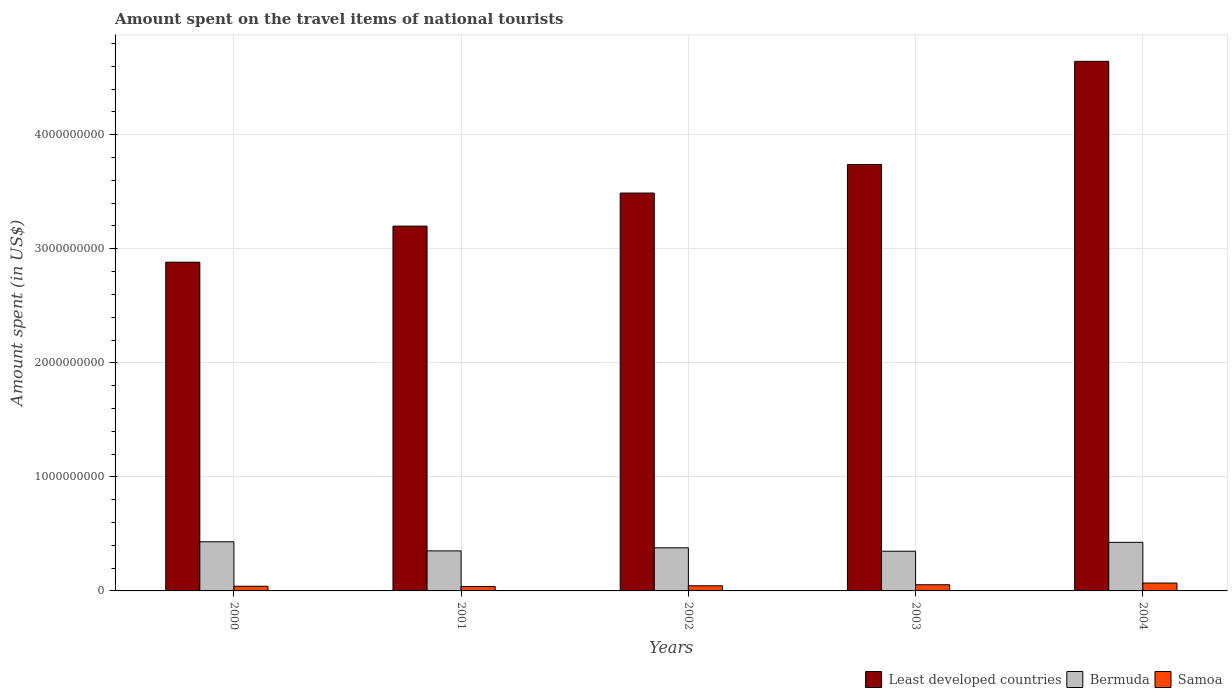How many different coloured bars are there?
Ensure brevity in your answer.  3. How many groups of bars are there?
Keep it short and to the point. 5. How many bars are there on the 4th tick from the left?
Your answer should be very brief. 3. How many bars are there on the 2nd tick from the right?
Provide a short and direct response. 3. In how many cases, is the number of bars for a given year not equal to the number of legend labels?
Make the answer very short. 0. What is the amount spent on the travel items of national tourists in Samoa in 2002?
Your answer should be compact. 4.50e+07. Across all years, what is the maximum amount spent on the travel items of national tourists in Least developed countries?
Your answer should be compact. 4.64e+09. Across all years, what is the minimum amount spent on the travel items of national tourists in Samoa?
Offer a terse response. 3.90e+07. In which year was the amount spent on the travel items of national tourists in Samoa maximum?
Provide a short and direct response. 2004. In which year was the amount spent on the travel items of national tourists in Bermuda minimum?
Your response must be concise. 2003. What is the total amount spent on the travel items of national tourists in Least developed countries in the graph?
Your response must be concise. 1.80e+1. What is the difference between the amount spent on the travel items of national tourists in Bermuda in 2001 and that in 2002?
Your answer should be very brief. -2.70e+07. What is the difference between the amount spent on the travel items of national tourists in Bermuda in 2000 and the amount spent on the travel items of national tourists in Samoa in 2002?
Give a very brief answer. 3.86e+08. What is the average amount spent on the travel items of national tourists in Bermuda per year?
Keep it short and to the point. 3.87e+08. In the year 2004, what is the difference between the amount spent on the travel items of national tourists in Samoa and amount spent on the travel items of national tourists in Bermuda?
Keep it short and to the point. -3.57e+08. In how many years, is the amount spent on the travel items of national tourists in Bermuda greater than 4600000000 US$?
Your answer should be compact. 0. What is the ratio of the amount spent on the travel items of national tourists in Samoa in 2001 to that in 2002?
Provide a short and direct response. 0.87. Is the amount spent on the travel items of national tourists in Samoa in 2000 less than that in 2003?
Keep it short and to the point. Yes. Is the difference between the amount spent on the travel items of national tourists in Samoa in 2000 and 2004 greater than the difference between the amount spent on the travel items of national tourists in Bermuda in 2000 and 2004?
Your answer should be compact. No. What is the difference between the highest and the second highest amount spent on the travel items of national tourists in Samoa?
Make the answer very short. 1.50e+07. What is the difference between the highest and the lowest amount spent on the travel items of national tourists in Samoa?
Your response must be concise. 3.00e+07. In how many years, is the amount spent on the travel items of national tourists in Bermuda greater than the average amount spent on the travel items of national tourists in Bermuda taken over all years?
Provide a short and direct response. 2. Is the sum of the amount spent on the travel items of national tourists in Bermuda in 2002 and 2004 greater than the maximum amount spent on the travel items of national tourists in Samoa across all years?
Offer a very short reply. Yes. What does the 3rd bar from the left in 2003 represents?
Provide a succinct answer. Samoa. What does the 3rd bar from the right in 2002 represents?
Your response must be concise. Least developed countries. Are all the bars in the graph horizontal?
Provide a short and direct response. No. Are the values on the major ticks of Y-axis written in scientific E-notation?
Keep it short and to the point. No. Where does the legend appear in the graph?
Give a very brief answer. Bottom right. How many legend labels are there?
Make the answer very short. 3. How are the legend labels stacked?
Make the answer very short. Horizontal. What is the title of the graph?
Make the answer very short. Amount spent on the travel items of national tourists. Does "Sub-Saharan Africa (developing only)" appear as one of the legend labels in the graph?
Offer a very short reply. No. What is the label or title of the Y-axis?
Offer a terse response. Amount spent (in US$). What is the Amount spent (in US$) in Least developed countries in 2000?
Your answer should be compact. 2.88e+09. What is the Amount spent (in US$) in Bermuda in 2000?
Ensure brevity in your answer.  4.31e+08. What is the Amount spent (in US$) in Samoa in 2000?
Make the answer very short. 4.10e+07. What is the Amount spent (in US$) in Least developed countries in 2001?
Your response must be concise. 3.20e+09. What is the Amount spent (in US$) of Bermuda in 2001?
Give a very brief answer. 3.51e+08. What is the Amount spent (in US$) of Samoa in 2001?
Give a very brief answer. 3.90e+07. What is the Amount spent (in US$) in Least developed countries in 2002?
Your answer should be compact. 3.49e+09. What is the Amount spent (in US$) of Bermuda in 2002?
Offer a terse response. 3.78e+08. What is the Amount spent (in US$) in Samoa in 2002?
Provide a succinct answer. 4.50e+07. What is the Amount spent (in US$) of Least developed countries in 2003?
Your answer should be very brief. 3.74e+09. What is the Amount spent (in US$) of Bermuda in 2003?
Offer a very short reply. 3.48e+08. What is the Amount spent (in US$) of Samoa in 2003?
Keep it short and to the point. 5.40e+07. What is the Amount spent (in US$) of Least developed countries in 2004?
Make the answer very short. 4.64e+09. What is the Amount spent (in US$) in Bermuda in 2004?
Provide a short and direct response. 4.26e+08. What is the Amount spent (in US$) in Samoa in 2004?
Your answer should be compact. 6.90e+07. Across all years, what is the maximum Amount spent (in US$) in Least developed countries?
Provide a short and direct response. 4.64e+09. Across all years, what is the maximum Amount spent (in US$) of Bermuda?
Provide a short and direct response. 4.31e+08. Across all years, what is the maximum Amount spent (in US$) in Samoa?
Your answer should be compact. 6.90e+07. Across all years, what is the minimum Amount spent (in US$) in Least developed countries?
Your response must be concise. 2.88e+09. Across all years, what is the minimum Amount spent (in US$) of Bermuda?
Offer a very short reply. 3.48e+08. Across all years, what is the minimum Amount spent (in US$) of Samoa?
Offer a terse response. 3.90e+07. What is the total Amount spent (in US$) in Least developed countries in the graph?
Give a very brief answer. 1.80e+1. What is the total Amount spent (in US$) of Bermuda in the graph?
Make the answer very short. 1.93e+09. What is the total Amount spent (in US$) in Samoa in the graph?
Ensure brevity in your answer.  2.48e+08. What is the difference between the Amount spent (in US$) of Least developed countries in 2000 and that in 2001?
Provide a short and direct response. -3.16e+08. What is the difference between the Amount spent (in US$) of Bermuda in 2000 and that in 2001?
Your answer should be very brief. 8.00e+07. What is the difference between the Amount spent (in US$) of Least developed countries in 2000 and that in 2002?
Make the answer very short. -6.06e+08. What is the difference between the Amount spent (in US$) in Bermuda in 2000 and that in 2002?
Make the answer very short. 5.30e+07. What is the difference between the Amount spent (in US$) in Samoa in 2000 and that in 2002?
Provide a succinct answer. -4.00e+06. What is the difference between the Amount spent (in US$) in Least developed countries in 2000 and that in 2003?
Make the answer very short. -8.57e+08. What is the difference between the Amount spent (in US$) of Bermuda in 2000 and that in 2003?
Your answer should be very brief. 8.30e+07. What is the difference between the Amount spent (in US$) in Samoa in 2000 and that in 2003?
Provide a succinct answer. -1.30e+07. What is the difference between the Amount spent (in US$) in Least developed countries in 2000 and that in 2004?
Provide a short and direct response. -1.76e+09. What is the difference between the Amount spent (in US$) of Bermuda in 2000 and that in 2004?
Keep it short and to the point. 5.00e+06. What is the difference between the Amount spent (in US$) of Samoa in 2000 and that in 2004?
Provide a succinct answer. -2.80e+07. What is the difference between the Amount spent (in US$) of Least developed countries in 2001 and that in 2002?
Ensure brevity in your answer.  -2.90e+08. What is the difference between the Amount spent (in US$) of Bermuda in 2001 and that in 2002?
Offer a terse response. -2.70e+07. What is the difference between the Amount spent (in US$) in Samoa in 2001 and that in 2002?
Provide a short and direct response. -6.00e+06. What is the difference between the Amount spent (in US$) in Least developed countries in 2001 and that in 2003?
Provide a short and direct response. -5.40e+08. What is the difference between the Amount spent (in US$) of Bermuda in 2001 and that in 2003?
Ensure brevity in your answer.  3.00e+06. What is the difference between the Amount spent (in US$) in Samoa in 2001 and that in 2003?
Ensure brevity in your answer.  -1.50e+07. What is the difference between the Amount spent (in US$) in Least developed countries in 2001 and that in 2004?
Your answer should be compact. -1.44e+09. What is the difference between the Amount spent (in US$) in Bermuda in 2001 and that in 2004?
Provide a short and direct response. -7.50e+07. What is the difference between the Amount spent (in US$) in Samoa in 2001 and that in 2004?
Keep it short and to the point. -3.00e+07. What is the difference between the Amount spent (in US$) of Least developed countries in 2002 and that in 2003?
Give a very brief answer. -2.50e+08. What is the difference between the Amount spent (in US$) in Bermuda in 2002 and that in 2003?
Ensure brevity in your answer.  3.00e+07. What is the difference between the Amount spent (in US$) in Samoa in 2002 and that in 2003?
Give a very brief answer. -9.00e+06. What is the difference between the Amount spent (in US$) in Least developed countries in 2002 and that in 2004?
Your response must be concise. -1.15e+09. What is the difference between the Amount spent (in US$) of Bermuda in 2002 and that in 2004?
Keep it short and to the point. -4.80e+07. What is the difference between the Amount spent (in US$) of Samoa in 2002 and that in 2004?
Your answer should be compact. -2.40e+07. What is the difference between the Amount spent (in US$) of Least developed countries in 2003 and that in 2004?
Provide a succinct answer. -9.05e+08. What is the difference between the Amount spent (in US$) in Bermuda in 2003 and that in 2004?
Make the answer very short. -7.80e+07. What is the difference between the Amount spent (in US$) in Samoa in 2003 and that in 2004?
Your answer should be compact. -1.50e+07. What is the difference between the Amount spent (in US$) in Least developed countries in 2000 and the Amount spent (in US$) in Bermuda in 2001?
Your response must be concise. 2.53e+09. What is the difference between the Amount spent (in US$) in Least developed countries in 2000 and the Amount spent (in US$) in Samoa in 2001?
Provide a short and direct response. 2.84e+09. What is the difference between the Amount spent (in US$) of Bermuda in 2000 and the Amount spent (in US$) of Samoa in 2001?
Keep it short and to the point. 3.92e+08. What is the difference between the Amount spent (in US$) in Least developed countries in 2000 and the Amount spent (in US$) in Bermuda in 2002?
Your answer should be very brief. 2.50e+09. What is the difference between the Amount spent (in US$) of Least developed countries in 2000 and the Amount spent (in US$) of Samoa in 2002?
Give a very brief answer. 2.84e+09. What is the difference between the Amount spent (in US$) of Bermuda in 2000 and the Amount spent (in US$) of Samoa in 2002?
Provide a short and direct response. 3.86e+08. What is the difference between the Amount spent (in US$) in Least developed countries in 2000 and the Amount spent (in US$) in Bermuda in 2003?
Give a very brief answer. 2.53e+09. What is the difference between the Amount spent (in US$) of Least developed countries in 2000 and the Amount spent (in US$) of Samoa in 2003?
Your answer should be compact. 2.83e+09. What is the difference between the Amount spent (in US$) in Bermuda in 2000 and the Amount spent (in US$) in Samoa in 2003?
Your answer should be very brief. 3.77e+08. What is the difference between the Amount spent (in US$) in Least developed countries in 2000 and the Amount spent (in US$) in Bermuda in 2004?
Your response must be concise. 2.46e+09. What is the difference between the Amount spent (in US$) in Least developed countries in 2000 and the Amount spent (in US$) in Samoa in 2004?
Make the answer very short. 2.81e+09. What is the difference between the Amount spent (in US$) in Bermuda in 2000 and the Amount spent (in US$) in Samoa in 2004?
Offer a terse response. 3.62e+08. What is the difference between the Amount spent (in US$) of Least developed countries in 2001 and the Amount spent (in US$) of Bermuda in 2002?
Provide a short and direct response. 2.82e+09. What is the difference between the Amount spent (in US$) in Least developed countries in 2001 and the Amount spent (in US$) in Samoa in 2002?
Keep it short and to the point. 3.15e+09. What is the difference between the Amount spent (in US$) in Bermuda in 2001 and the Amount spent (in US$) in Samoa in 2002?
Your response must be concise. 3.06e+08. What is the difference between the Amount spent (in US$) of Least developed countries in 2001 and the Amount spent (in US$) of Bermuda in 2003?
Give a very brief answer. 2.85e+09. What is the difference between the Amount spent (in US$) in Least developed countries in 2001 and the Amount spent (in US$) in Samoa in 2003?
Your response must be concise. 3.14e+09. What is the difference between the Amount spent (in US$) of Bermuda in 2001 and the Amount spent (in US$) of Samoa in 2003?
Ensure brevity in your answer.  2.97e+08. What is the difference between the Amount spent (in US$) in Least developed countries in 2001 and the Amount spent (in US$) in Bermuda in 2004?
Make the answer very short. 2.77e+09. What is the difference between the Amount spent (in US$) of Least developed countries in 2001 and the Amount spent (in US$) of Samoa in 2004?
Ensure brevity in your answer.  3.13e+09. What is the difference between the Amount spent (in US$) in Bermuda in 2001 and the Amount spent (in US$) in Samoa in 2004?
Your answer should be very brief. 2.82e+08. What is the difference between the Amount spent (in US$) in Least developed countries in 2002 and the Amount spent (in US$) in Bermuda in 2003?
Your answer should be very brief. 3.14e+09. What is the difference between the Amount spent (in US$) of Least developed countries in 2002 and the Amount spent (in US$) of Samoa in 2003?
Offer a terse response. 3.43e+09. What is the difference between the Amount spent (in US$) in Bermuda in 2002 and the Amount spent (in US$) in Samoa in 2003?
Ensure brevity in your answer.  3.24e+08. What is the difference between the Amount spent (in US$) in Least developed countries in 2002 and the Amount spent (in US$) in Bermuda in 2004?
Your response must be concise. 3.06e+09. What is the difference between the Amount spent (in US$) of Least developed countries in 2002 and the Amount spent (in US$) of Samoa in 2004?
Your response must be concise. 3.42e+09. What is the difference between the Amount spent (in US$) in Bermuda in 2002 and the Amount spent (in US$) in Samoa in 2004?
Give a very brief answer. 3.09e+08. What is the difference between the Amount spent (in US$) of Least developed countries in 2003 and the Amount spent (in US$) of Bermuda in 2004?
Ensure brevity in your answer.  3.31e+09. What is the difference between the Amount spent (in US$) in Least developed countries in 2003 and the Amount spent (in US$) in Samoa in 2004?
Keep it short and to the point. 3.67e+09. What is the difference between the Amount spent (in US$) in Bermuda in 2003 and the Amount spent (in US$) in Samoa in 2004?
Ensure brevity in your answer.  2.79e+08. What is the average Amount spent (in US$) of Least developed countries per year?
Offer a terse response. 3.59e+09. What is the average Amount spent (in US$) of Bermuda per year?
Give a very brief answer. 3.87e+08. What is the average Amount spent (in US$) of Samoa per year?
Your answer should be compact. 4.96e+07. In the year 2000, what is the difference between the Amount spent (in US$) in Least developed countries and Amount spent (in US$) in Bermuda?
Provide a short and direct response. 2.45e+09. In the year 2000, what is the difference between the Amount spent (in US$) in Least developed countries and Amount spent (in US$) in Samoa?
Give a very brief answer. 2.84e+09. In the year 2000, what is the difference between the Amount spent (in US$) in Bermuda and Amount spent (in US$) in Samoa?
Your answer should be compact. 3.90e+08. In the year 2001, what is the difference between the Amount spent (in US$) in Least developed countries and Amount spent (in US$) in Bermuda?
Your answer should be very brief. 2.85e+09. In the year 2001, what is the difference between the Amount spent (in US$) of Least developed countries and Amount spent (in US$) of Samoa?
Your answer should be very brief. 3.16e+09. In the year 2001, what is the difference between the Amount spent (in US$) of Bermuda and Amount spent (in US$) of Samoa?
Ensure brevity in your answer.  3.12e+08. In the year 2002, what is the difference between the Amount spent (in US$) in Least developed countries and Amount spent (in US$) in Bermuda?
Ensure brevity in your answer.  3.11e+09. In the year 2002, what is the difference between the Amount spent (in US$) in Least developed countries and Amount spent (in US$) in Samoa?
Offer a terse response. 3.44e+09. In the year 2002, what is the difference between the Amount spent (in US$) of Bermuda and Amount spent (in US$) of Samoa?
Your answer should be very brief. 3.33e+08. In the year 2003, what is the difference between the Amount spent (in US$) of Least developed countries and Amount spent (in US$) of Bermuda?
Make the answer very short. 3.39e+09. In the year 2003, what is the difference between the Amount spent (in US$) in Least developed countries and Amount spent (in US$) in Samoa?
Give a very brief answer. 3.68e+09. In the year 2003, what is the difference between the Amount spent (in US$) in Bermuda and Amount spent (in US$) in Samoa?
Give a very brief answer. 2.94e+08. In the year 2004, what is the difference between the Amount spent (in US$) of Least developed countries and Amount spent (in US$) of Bermuda?
Provide a short and direct response. 4.22e+09. In the year 2004, what is the difference between the Amount spent (in US$) in Least developed countries and Amount spent (in US$) in Samoa?
Give a very brief answer. 4.57e+09. In the year 2004, what is the difference between the Amount spent (in US$) of Bermuda and Amount spent (in US$) of Samoa?
Your answer should be compact. 3.57e+08. What is the ratio of the Amount spent (in US$) in Least developed countries in 2000 to that in 2001?
Provide a short and direct response. 0.9. What is the ratio of the Amount spent (in US$) of Bermuda in 2000 to that in 2001?
Ensure brevity in your answer.  1.23. What is the ratio of the Amount spent (in US$) of Samoa in 2000 to that in 2001?
Ensure brevity in your answer.  1.05. What is the ratio of the Amount spent (in US$) of Least developed countries in 2000 to that in 2002?
Keep it short and to the point. 0.83. What is the ratio of the Amount spent (in US$) in Bermuda in 2000 to that in 2002?
Provide a short and direct response. 1.14. What is the ratio of the Amount spent (in US$) in Samoa in 2000 to that in 2002?
Your answer should be compact. 0.91. What is the ratio of the Amount spent (in US$) in Least developed countries in 2000 to that in 2003?
Offer a terse response. 0.77. What is the ratio of the Amount spent (in US$) of Bermuda in 2000 to that in 2003?
Provide a short and direct response. 1.24. What is the ratio of the Amount spent (in US$) of Samoa in 2000 to that in 2003?
Provide a short and direct response. 0.76. What is the ratio of the Amount spent (in US$) of Least developed countries in 2000 to that in 2004?
Your answer should be compact. 0.62. What is the ratio of the Amount spent (in US$) in Bermuda in 2000 to that in 2004?
Your response must be concise. 1.01. What is the ratio of the Amount spent (in US$) in Samoa in 2000 to that in 2004?
Keep it short and to the point. 0.59. What is the ratio of the Amount spent (in US$) in Least developed countries in 2001 to that in 2002?
Provide a short and direct response. 0.92. What is the ratio of the Amount spent (in US$) in Samoa in 2001 to that in 2002?
Provide a succinct answer. 0.87. What is the ratio of the Amount spent (in US$) of Least developed countries in 2001 to that in 2003?
Provide a succinct answer. 0.86. What is the ratio of the Amount spent (in US$) of Bermuda in 2001 to that in 2003?
Offer a very short reply. 1.01. What is the ratio of the Amount spent (in US$) in Samoa in 2001 to that in 2003?
Give a very brief answer. 0.72. What is the ratio of the Amount spent (in US$) of Least developed countries in 2001 to that in 2004?
Provide a succinct answer. 0.69. What is the ratio of the Amount spent (in US$) of Bermuda in 2001 to that in 2004?
Make the answer very short. 0.82. What is the ratio of the Amount spent (in US$) in Samoa in 2001 to that in 2004?
Keep it short and to the point. 0.57. What is the ratio of the Amount spent (in US$) in Least developed countries in 2002 to that in 2003?
Ensure brevity in your answer.  0.93. What is the ratio of the Amount spent (in US$) in Bermuda in 2002 to that in 2003?
Your answer should be very brief. 1.09. What is the ratio of the Amount spent (in US$) in Least developed countries in 2002 to that in 2004?
Your response must be concise. 0.75. What is the ratio of the Amount spent (in US$) of Bermuda in 2002 to that in 2004?
Your answer should be very brief. 0.89. What is the ratio of the Amount spent (in US$) in Samoa in 2002 to that in 2004?
Offer a terse response. 0.65. What is the ratio of the Amount spent (in US$) in Least developed countries in 2003 to that in 2004?
Offer a very short reply. 0.81. What is the ratio of the Amount spent (in US$) of Bermuda in 2003 to that in 2004?
Provide a short and direct response. 0.82. What is the ratio of the Amount spent (in US$) in Samoa in 2003 to that in 2004?
Your response must be concise. 0.78. What is the difference between the highest and the second highest Amount spent (in US$) of Least developed countries?
Give a very brief answer. 9.05e+08. What is the difference between the highest and the second highest Amount spent (in US$) of Bermuda?
Provide a succinct answer. 5.00e+06. What is the difference between the highest and the second highest Amount spent (in US$) in Samoa?
Give a very brief answer. 1.50e+07. What is the difference between the highest and the lowest Amount spent (in US$) of Least developed countries?
Keep it short and to the point. 1.76e+09. What is the difference between the highest and the lowest Amount spent (in US$) of Bermuda?
Ensure brevity in your answer.  8.30e+07. What is the difference between the highest and the lowest Amount spent (in US$) of Samoa?
Your response must be concise. 3.00e+07. 